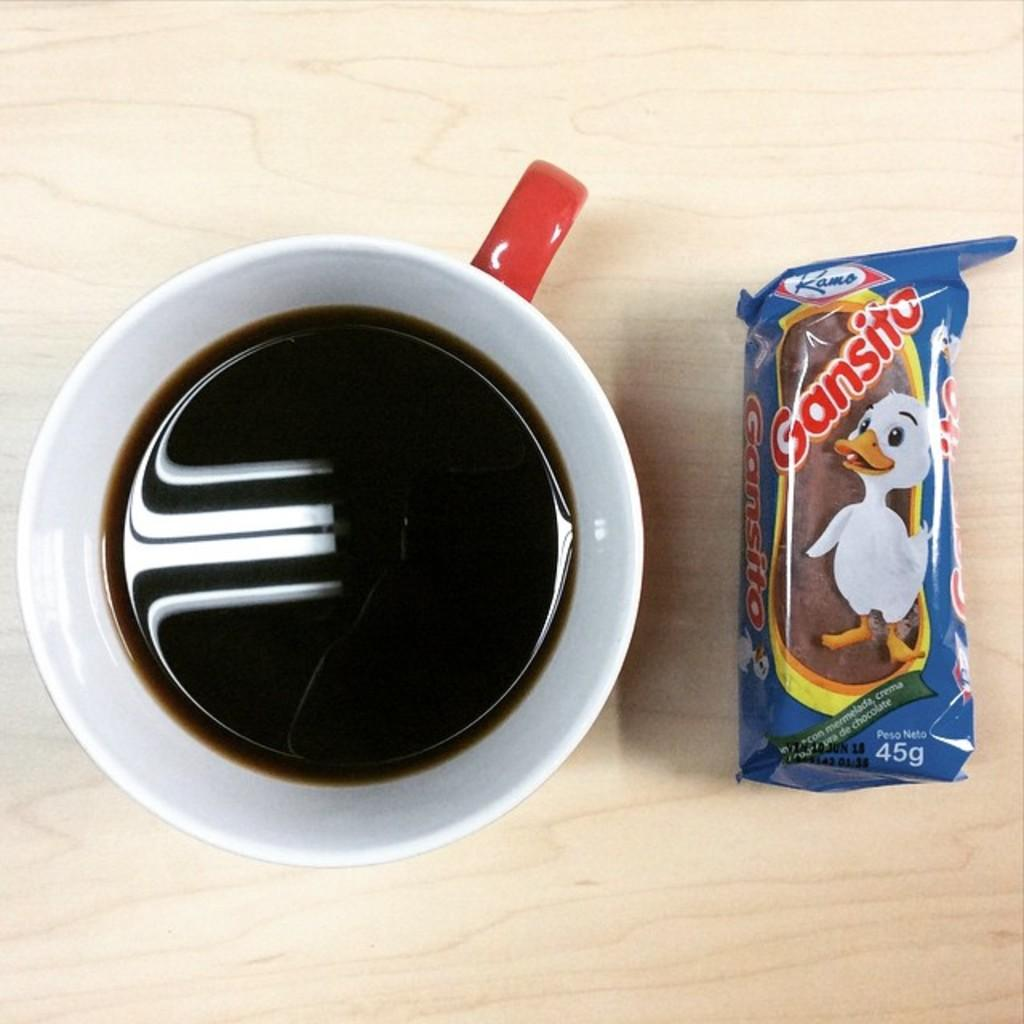What type of dishware is visible in the image? There is a tea cup in the image. What food item is associated with the tea cup? There is a biscuit packet in the image. What material is the surface that the tea cup and biscuit packet are placed on? The wooden surface is present in the image. What type of impulse can be seen traveling through the wooden surface in the image? There is no impulse visible in the image; it is a still image of a tea cup, biscuit packet, and wooden surface. 